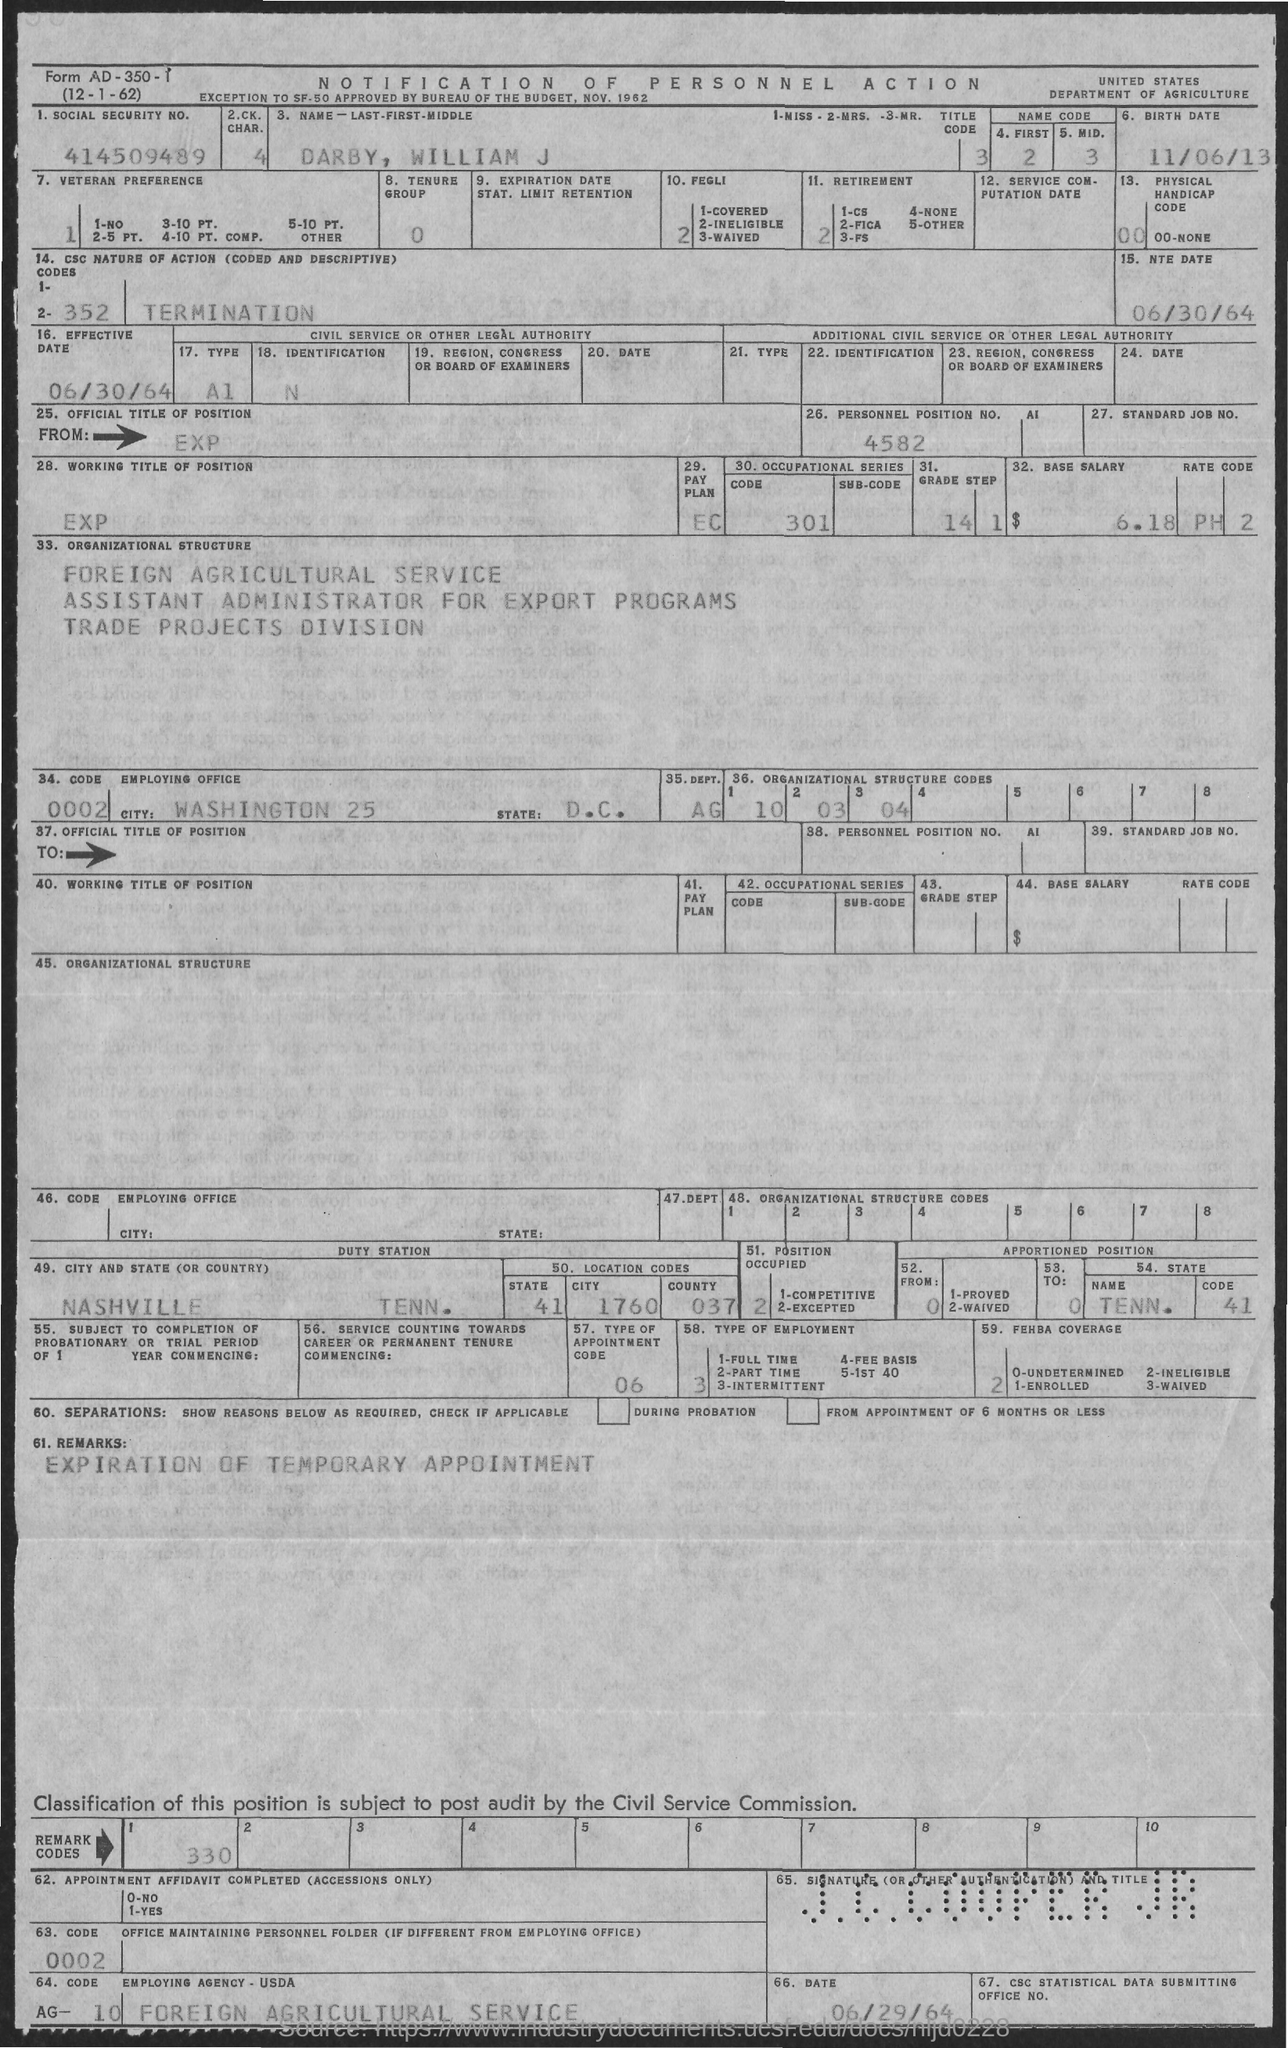Specify some key components in this picture. The birthdate of DARBY, WILLIAM J is November 6, 2013. The Social Security Number provided in the document is 414509489. The Personal Position No. given in the document is 4582. According to the document, William J. Darby is employed by the Foreign Agricultural Service. The NTE date mentioned in the document is June 30, 1964. 